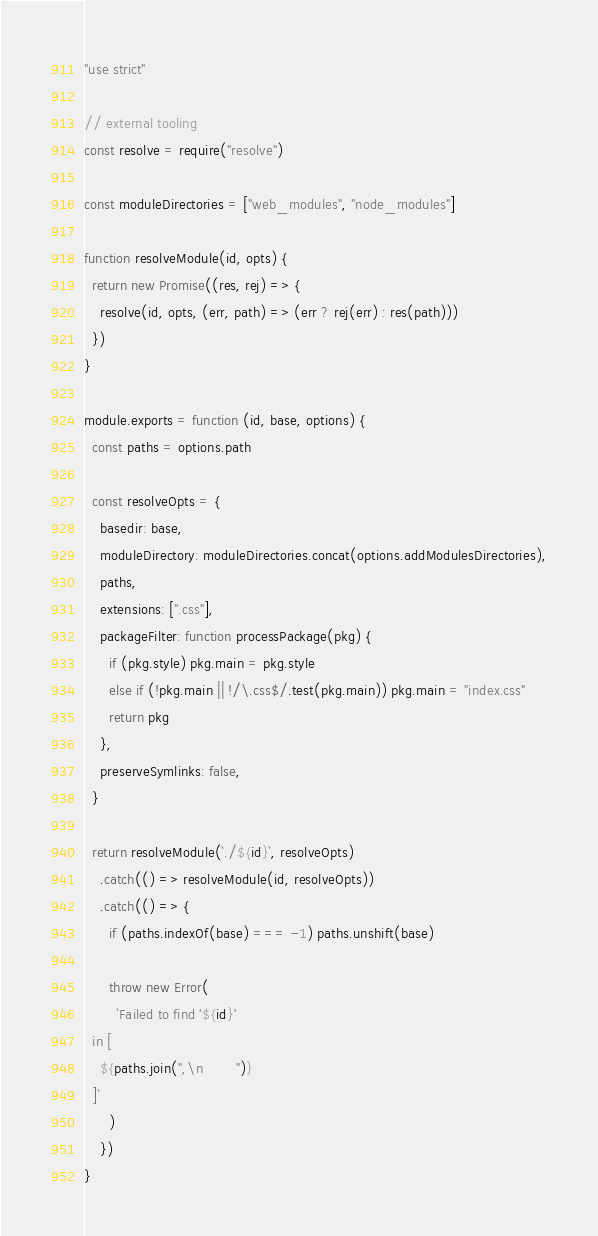<code> <loc_0><loc_0><loc_500><loc_500><_JavaScript_>"use strict"

// external tooling
const resolve = require("resolve")

const moduleDirectories = ["web_modules", "node_modules"]

function resolveModule(id, opts) {
  return new Promise((res, rej) => {
    resolve(id, opts, (err, path) => (err ? rej(err) : res(path)))
  })
}

module.exports = function (id, base, options) {
  const paths = options.path

  const resolveOpts = {
    basedir: base,
    moduleDirectory: moduleDirectories.concat(options.addModulesDirectories),
    paths,
    extensions: [".css"],
    packageFilter: function processPackage(pkg) {
      if (pkg.style) pkg.main = pkg.style
      else if (!pkg.main || !/\.css$/.test(pkg.main)) pkg.main = "index.css"
      return pkg
    },
    preserveSymlinks: false,
  }

  return resolveModule(`./${id}`, resolveOpts)
    .catch(() => resolveModule(id, resolveOpts))
    .catch(() => {
      if (paths.indexOf(base) === -1) paths.unshift(base)

      throw new Error(
        `Failed to find '${id}'
  in [
    ${paths.join(",\n        ")}
  ]`
      )
    })
}
</code> 